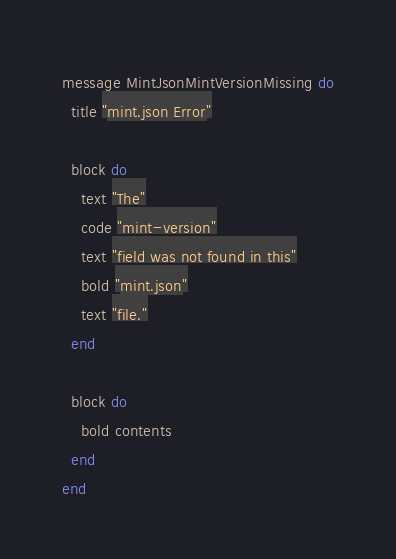Convert code to text. <code><loc_0><loc_0><loc_500><loc_500><_Crystal_>message MintJsonMintVersionMissing do
  title "mint.json Error"

  block do
    text "The"
    code "mint-version"
    text "field was not found in this"
    bold "mint.json"
    text "file."
  end

  block do
    bold contents
  end
end
</code> 